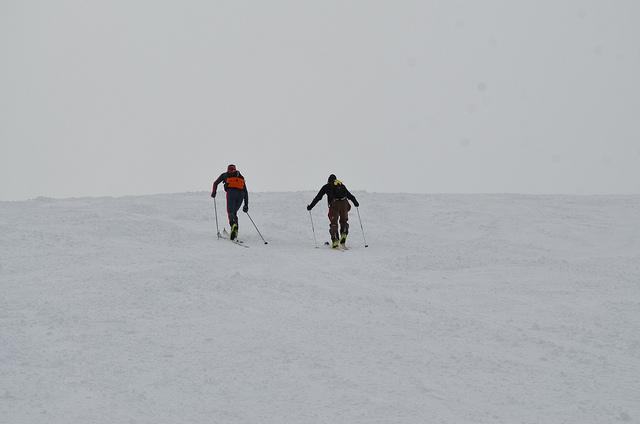Are these two men?
Short answer required. Yes. Where is this picture taken?
Concise answer only. Mountain. Are the girls on the beach?
Keep it brief. No. Is the snow being kicked up by the skiers?
Quick response, please. No. Is it snowing?
Quick response, please. No. Is this person skiing downhill?
Answer briefly. No. What are these people doing?
Be succinct. Skiing. 